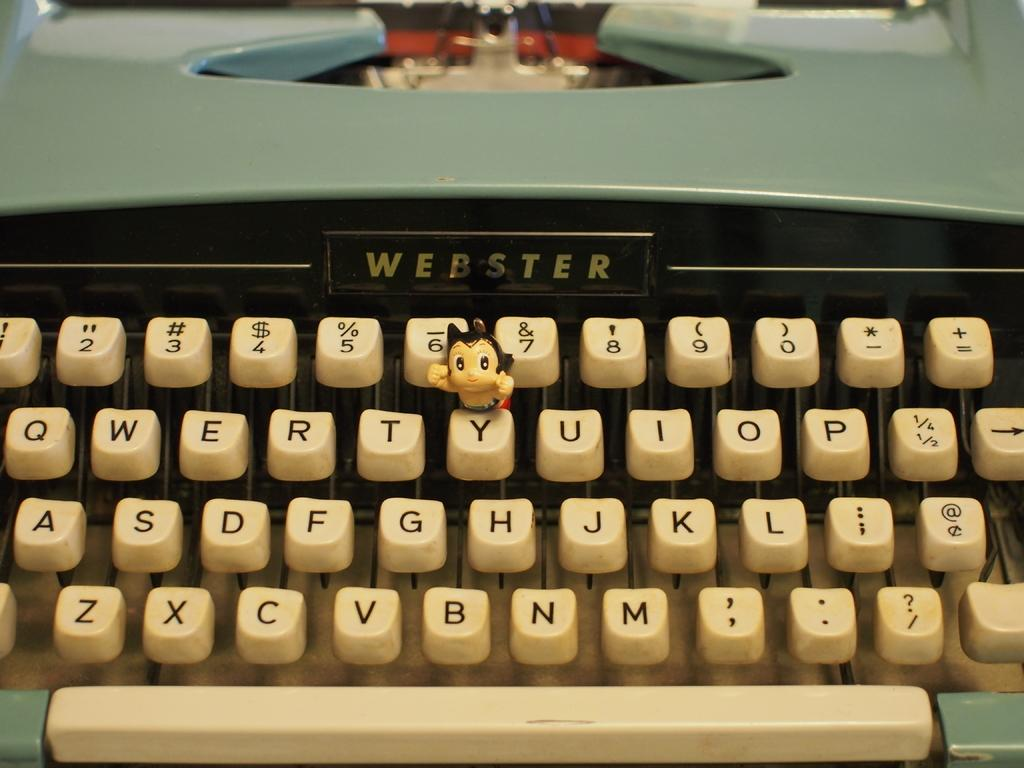<image>
Present a compact description of the photo's key features. An old Webster type writer is a figurine on the Y key. 